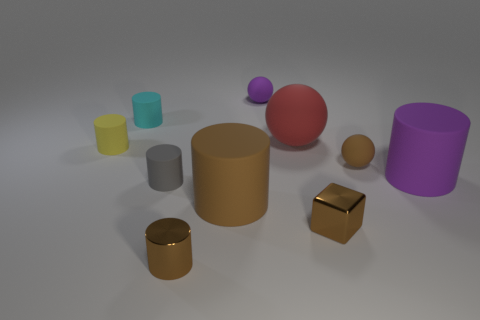Subtract all big cylinders. How many cylinders are left? 4 Subtract all red spheres. How many brown cylinders are left? 2 Subtract all gray cylinders. How many cylinders are left? 5 Subtract all spheres. How many objects are left? 7 Subtract all blue cylinders. Subtract all cyan cubes. How many cylinders are left? 6 Subtract 0 cyan spheres. How many objects are left? 10 Subtract all small yellow matte things. Subtract all red matte things. How many objects are left? 8 Add 8 small purple balls. How many small purple balls are left? 9 Add 3 small gray cylinders. How many small gray cylinders exist? 4 